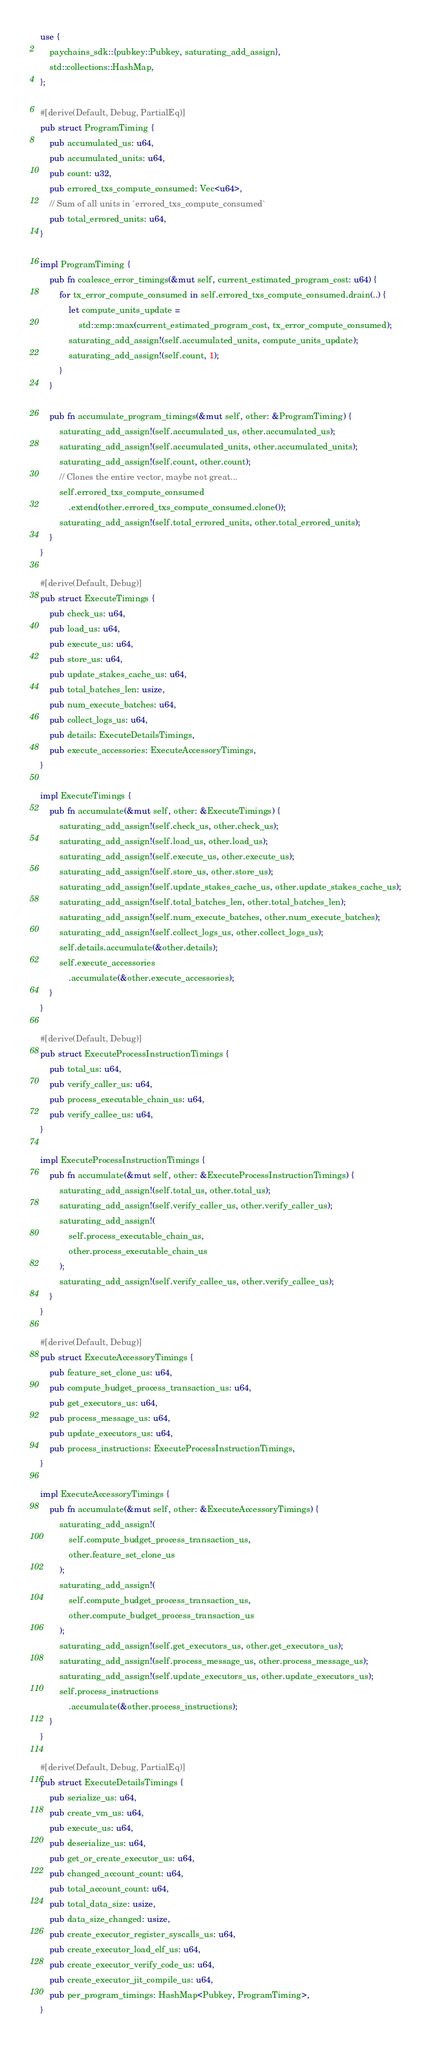Convert code to text. <code><loc_0><loc_0><loc_500><loc_500><_Rust_>use {
    paychains_sdk::{pubkey::Pubkey, saturating_add_assign},
    std::collections::HashMap,
};

#[derive(Default, Debug, PartialEq)]
pub struct ProgramTiming {
    pub accumulated_us: u64,
    pub accumulated_units: u64,
    pub count: u32,
    pub errored_txs_compute_consumed: Vec<u64>,
    // Sum of all units in `errored_txs_compute_consumed`
    pub total_errored_units: u64,
}

impl ProgramTiming {
    pub fn coalesce_error_timings(&mut self, current_estimated_program_cost: u64) {
        for tx_error_compute_consumed in self.errored_txs_compute_consumed.drain(..) {
            let compute_units_update =
                std::cmp::max(current_estimated_program_cost, tx_error_compute_consumed);
            saturating_add_assign!(self.accumulated_units, compute_units_update);
            saturating_add_assign!(self.count, 1);
        }
    }

    pub fn accumulate_program_timings(&mut self, other: &ProgramTiming) {
        saturating_add_assign!(self.accumulated_us, other.accumulated_us);
        saturating_add_assign!(self.accumulated_units, other.accumulated_units);
        saturating_add_assign!(self.count, other.count);
        // Clones the entire vector, maybe not great...
        self.errored_txs_compute_consumed
            .extend(other.errored_txs_compute_consumed.clone());
        saturating_add_assign!(self.total_errored_units, other.total_errored_units);
    }
}

#[derive(Default, Debug)]
pub struct ExecuteTimings {
    pub check_us: u64,
    pub load_us: u64,
    pub execute_us: u64,
    pub store_us: u64,
    pub update_stakes_cache_us: u64,
    pub total_batches_len: usize,
    pub num_execute_batches: u64,
    pub collect_logs_us: u64,
    pub details: ExecuteDetailsTimings,
    pub execute_accessories: ExecuteAccessoryTimings,
}

impl ExecuteTimings {
    pub fn accumulate(&mut self, other: &ExecuteTimings) {
        saturating_add_assign!(self.check_us, other.check_us);
        saturating_add_assign!(self.load_us, other.load_us);
        saturating_add_assign!(self.execute_us, other.execute_us);
        saturating_add_assign!(self.store_us, other.store_us);
        saturating_add_assign!(self.update_stakes_cache_us, other.update_stakes_cache_us);
        saturating_add_assign!(self.total_batches_len, other.total_batches_len);
        saturating_add_assign!(self.num_execute_batches, other.num_execute_batches);
        saturating_add_assign!(self.collect_logs_us, other.collect_logs_us);
        self.details.accumulate(&other.details);
        self.execute_accessories
            .accumulate(&other.execute_accessories);
    }
}

#[derive(Default, Debug)]
pub struct ExecuteProcessInstructionTimings {
    pub total_us: u64,
    pub verify_caller_us: u64,
    pub process_executable_chain_us: u64,
    pub verify_callee_us: u64,
}

impl ExecuteProcessInstructionTimings {
    pub fn accumulate(&mut self, other: &ExecuteProcessInstructionTimings) {
        saturating_add_assign!(self.total_us, other.total_us);
        saturating_add_assign!(self.verify_caller_us, other.verify_caller_us);
        saturating_add_assign!(
            self.process_executable_chain_us,
            other.process_executable_chain_us
        );
        saturating_add_assign!(self.verify_callee_us, other.verify_callee_us);
    }
}

#[derive(Default, Debug)]
pub struct ExecuteAccessoryTimings {
    pub feature_set_clone_us: u64,
    pub compute_budget_process_transaction_us: u64,
    pub get_executors_us: u64,
    pub process_message_us: u64,
    pub update_executors_us: u64,
    pub process_instructions: ExecuteProcessInstructionTimings,
}

impl ExecuteAccessoryTimings {
    pub fn accumulate(&mut self, other: &ExecuteAccessoryTimings) {
        saturating_add_assign!(
            self.compute_budget_process_transaction_us,
            other.feature_set_clone_us
        );
        saturating_add_assign!(
            self.compute_budget_process_transaction_us,
            other.compute_budget_process_transaction_us
        );
        saturating_add_assign!(self.get_executors_us, other.get_executors_us);
        saturating_add_assign!(self.process_message_us, other.process_message_us);
        saturating_add_assign!(self.update_executors_us, other.update_executors_us);
        self.process_instructions
            .accumulate(&other.process_instructions);
    }
}

#[derive(Default, Debug, PartialEq)]
pub struct ExecuteDetailsTimings {
    pub serialize_us: u64,
    pub create_vm_us: u64,
    pub execute_us: u64,
    pub deserialize_us: u64,
    pub get_or_create_executor_us: u64,
    pub changed_account_count: u64,
    pub total_account_count: u64,
    pub total_data_size: usize,
    pub data_size_changed: usize,
    pub create_executor_register_syscalls_us: u64,
    pub create_executor_load_elf_us: u64,
    pub create_executor_verify_code_us: u64,
    pub create_executor_jit_compile_us: u64,
    pub per_program_timings: HashMap<Pubkey, ProgramTiming>,
}</code> 